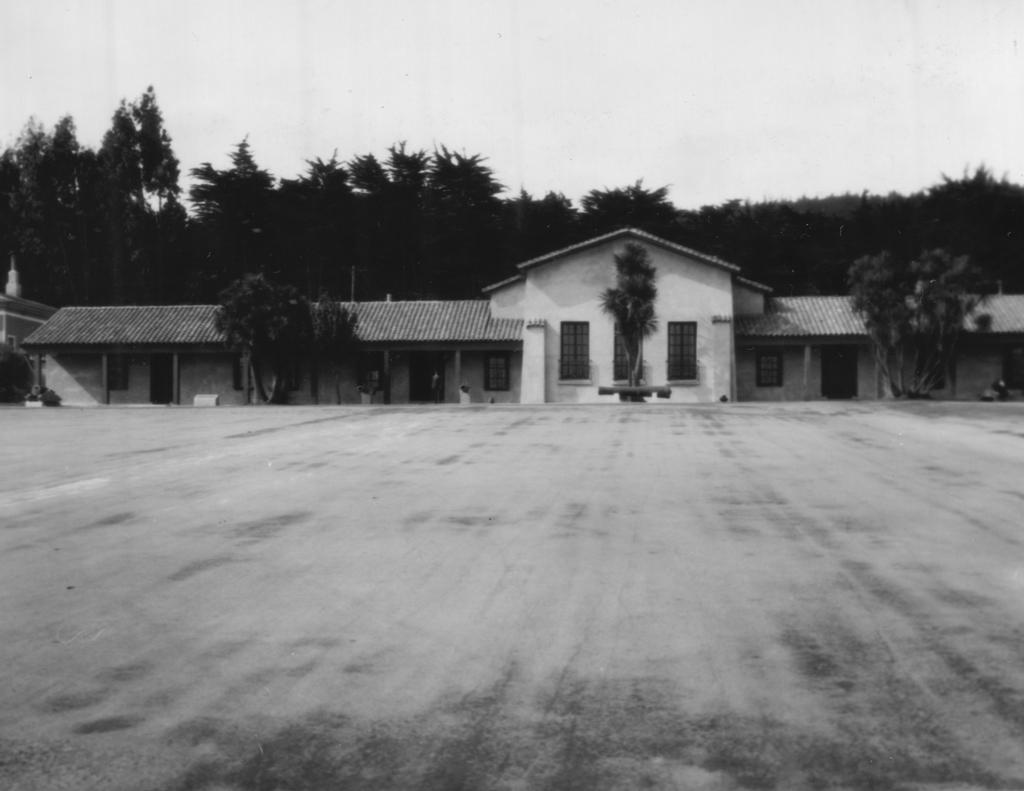What type of picture is in the image? The image contains a black and white picture. What is the main subject of the picture? The picture depicts the ground. What natural elements can be seen in the picture? There are trees in the picture. What man-made structure is present in the picture? There is a building in the picture. What can be seen in the background of the picture? The sky is visible in the background of the picture. Can you tell me how many birds are flying over the stream in the image? There is no stream or birds present in the image; it features a black and white picture of the ground, trees, a building, and the sky. 